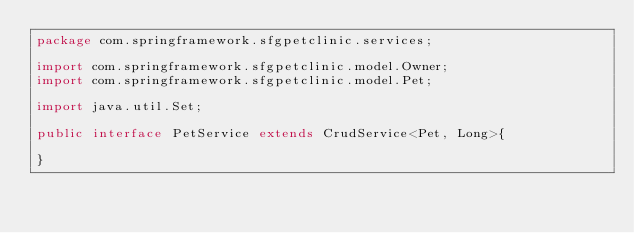Convert code to text. <code><loc_0><loc_0><loc_500><loc_500><_Java_>package com.springframework.sfgpetclinic.services;

import com.springframework.sfgpetclinic.model.Owner;
import com.springframework.sfgpetclinic.model.Pet;

import java.util.Set;

public interface PetService extends CrudService<Pet, Long>{

}
</code> 